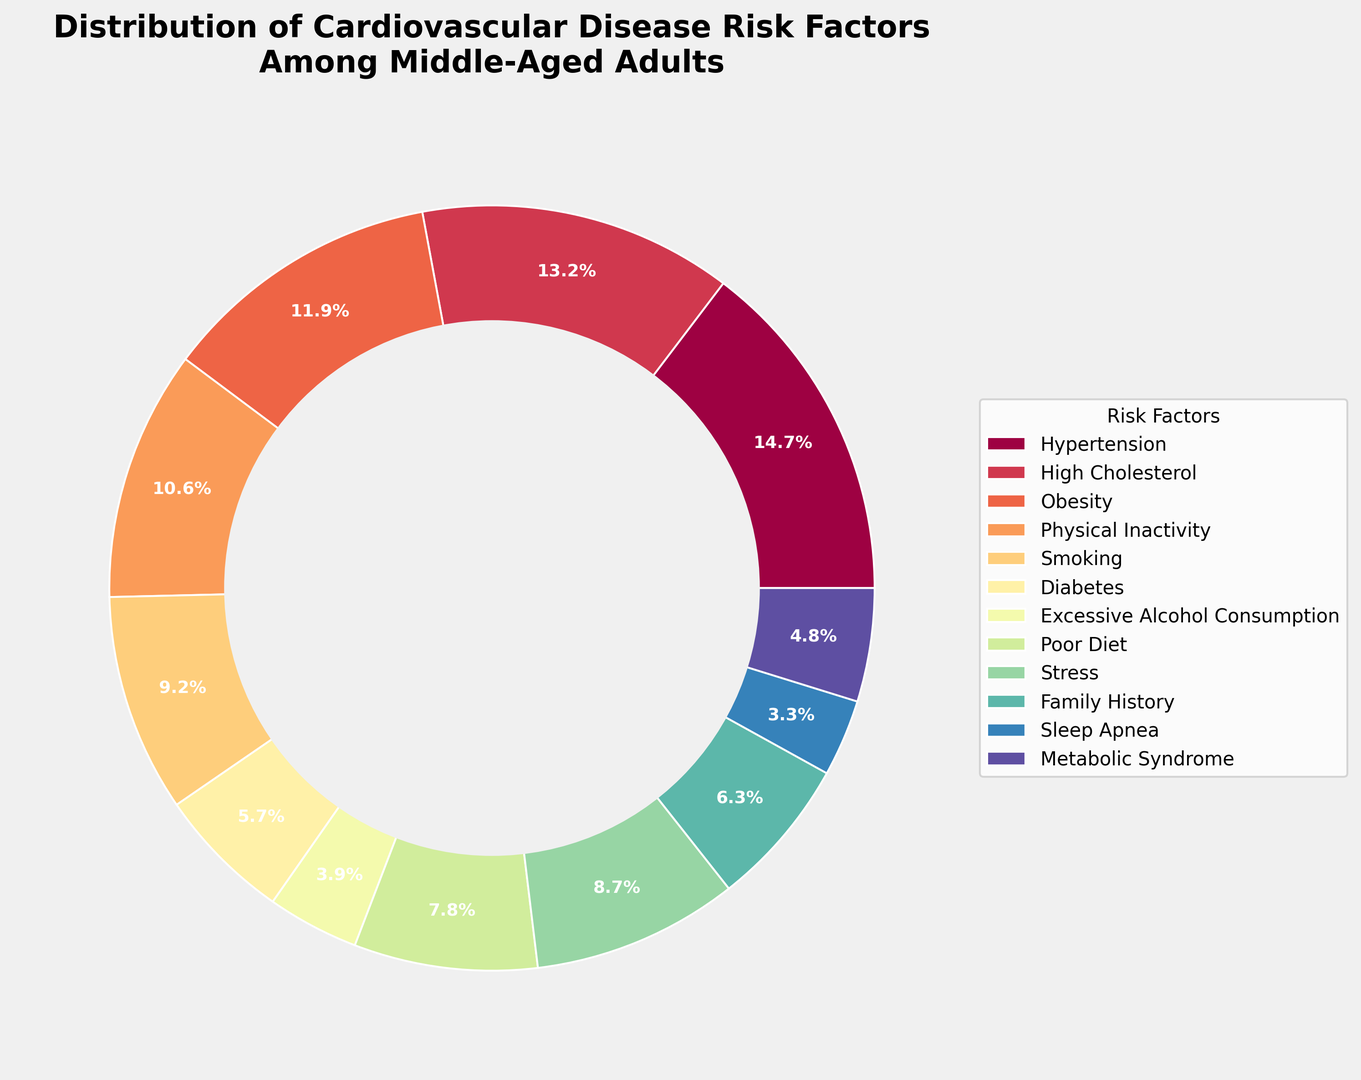What's the percentage of middle-aged adults with both Hypertension and High Cholesterol? The figure shows percentages for each risk factor individually. To find the combined percentage of Hypertension and High Cholesterol, we sum the two percentages: 35.2% for Hypertension and 31.8% for High Cholesterol. So, the combined percentage is 35.2 + 31.8 = 67.0%.
Answer: 67.0% Which risk factor has the lowest percentage? By examining the figure, we see that Sleep Apnea has the smallest wedge in the ring chart. Its percentage is 7.8%.
Answer: Sleep Apnea Is Physical Inactivity more common than Smoking? To compare Physical Inactivity and Smoking, we look at their respective percentages in the ring chart. Physical Inactivity is 25.4%, and Smoking is 22.1%. Since 25.4% is greater than 22.1%, Physical Inactivity is more common.
Answer: Yes What's the difference in percentage between Obesity and Stress? The percentage for Obesity is 28.5%, and for Stress, it’s 20.9%. We subtract the percentage of Stress from Obesity: 28.5 - 20.9 = 7.6 percentage points.
Answer: 7.6 percentage points Which risk factor is represented with the darkest color in the ring chart? The darkest color in the pie chart is typically applied to the highest percentage, which is Hypertension at 35.2%.
Answer: Hypertension What is the average percentage of Diabetes, Excessive Alcohol Consumption, and Sleep Apnea? To find the average percentage, we sum the percentages of Diabetes (13.7%), Excessive Alcohol Consumption (9.3%), and Sleep Apnea (7.8%), and then divide by the number of risk factors: (13.7 + 9.3 + 7.8) / 3 = 10.27%.
Answer: 10.27% Are there more middle-aged adults with a Poor Diet or those with Metabolic Syndrome? The figure shows percentages for each risk factor. Poor Diet is 18.6%, and Metabolic Syndrome is 11.5%. Since 18.6% is greater than 11.5%, there are more middle-aged adults with a Poor Diet.
Answer: Yes How much higher is the percentage of High Cholesterol compared to Family History? High Cholesterol has a percentage of 31.8%, and Family History is at 15.2%. The difference is found by subtracting Family History’s percentage from that of High Cholesterol: 31.8 - 15.2 = 16.6 percentage points.
Answer: 16.6 percentage points What is the combined percentage of physical and lifestyle-related risk factors (Obesity, Physical Inactivity, Smoking, Excessive Alcohol Consumption, Poor Diet, Stress)? To find this combined percentage, sum the individual percentages for these risk factors: Obesity (28.5%), Physical Inactivity (25.4%), Smoking (22.1%), Excessive Alcohol Consumption (9.3%), Poor Diet (18.6%), and Stress (20.9%). (28.5 + 25.4 + 22.1 + 9.3 + 18.6 + 20.9) = 124.8%.
Answer: 124.8% 